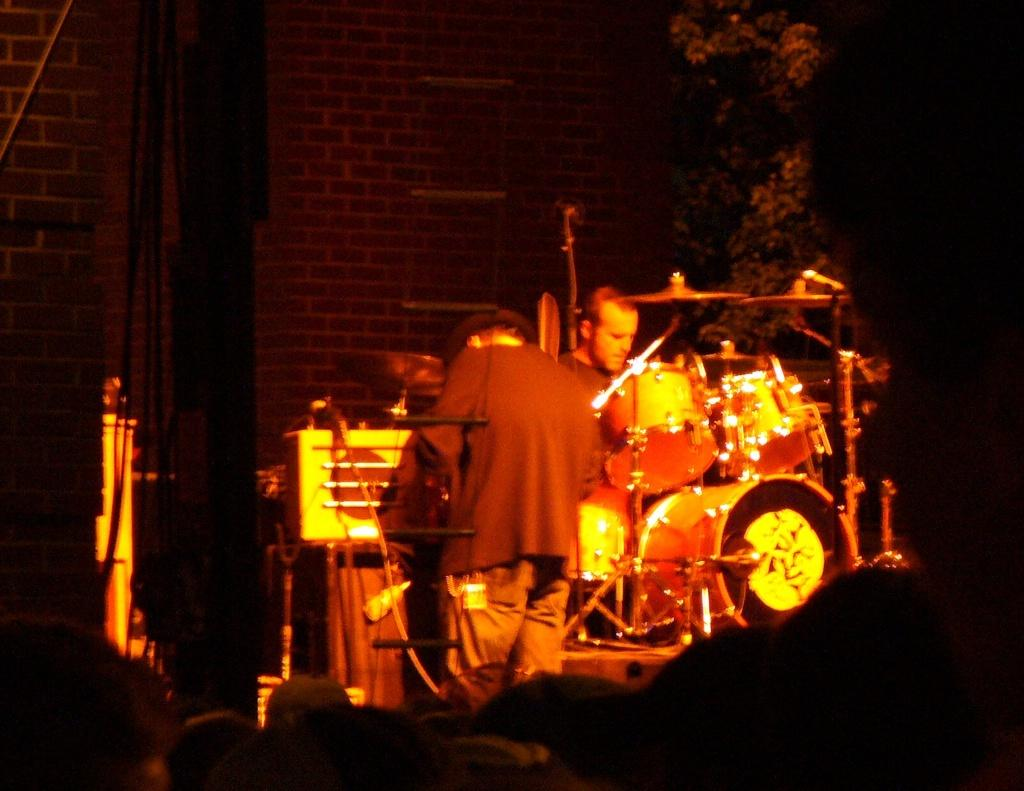How many people are on the stage in the image? There are two people on the stage in the image. What can be seen in front of the people on the stage? There are music instruments in front of the people. What type of natural element is visible in the image? There is a tree visible in the image. What type of structure is present in the image? There is a wall in the image. What type of glove is being smashed by the pie in the image? There is no glove or pie present in the image. 